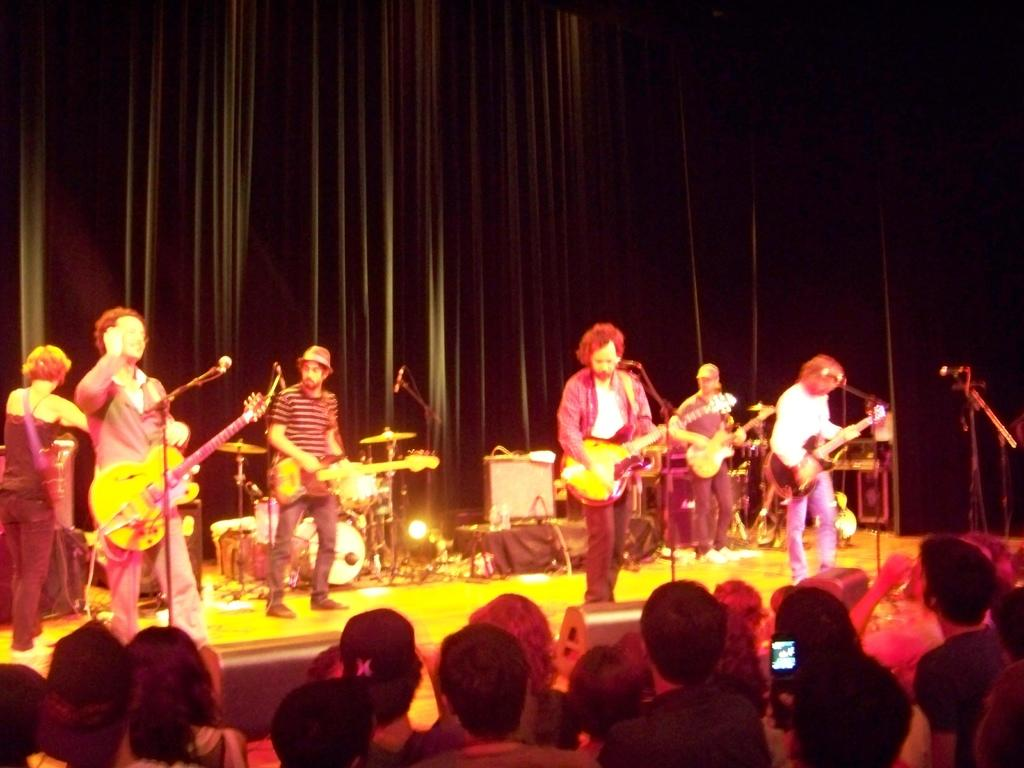What are the persons in the image doing? There is a group of persons playing guitar in the image. Where are they located in relation to the microphone? They are in front of a microphone. What type of setting is the group performing in? They are on a stage. Who is present in front of the group? There is an audience in front of them. What is the color of the background in the image? The background is black in color. What type of paint is being used to create a mural on the stage? There is no mention of a mural or paint in the image. How many bombs are visible on the stage during the performance? There are no bombs present in the image; the group is playing guitar on a stage. 